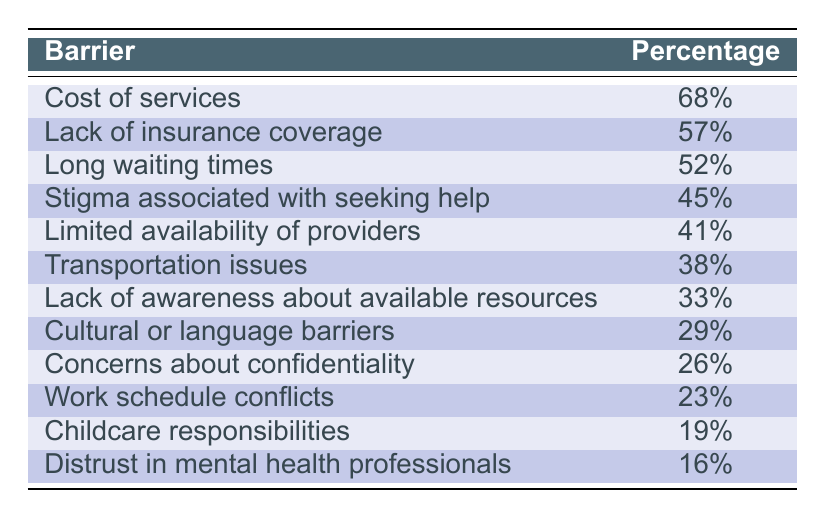What is the most commonly reported barrier to accessing mental health services? The table indicates that the "Cost of services" barrier has the highest percentage, reported by 68% of respondents.
Answer: Cost of services How many barriers have a percentage of 40% or higher? By counting the rows in the table, there are six barriers with percentages of 40% or higher: Cost of services (68%), Lack of insurance coverage (57%), Long waiting times (52%), Stigma associated with seeking help (45%), Limited availability of providers (41%).
Answer: 6 Is "Concerns about confidentiality" the least reported barrier? The "Concerns about confidentiality" barrier is reported at 26%. The least reported barrier is "Distrust in mental health professionals," with 16%. Therefore, the statement is false.
Answer: No What is the difference in percentage between the most and least reported barriers? The most reported barrier, "Cost of services," is at 68% and the least reported, "Distrust in mental health professionals," is at 16%. The difference is 68% - 16% = 52%.
Answer: 52% Which barrier has a higher percentage: "Transportation issues" or "Cultural or language barriers"? "Transportation issues" has a percentage of 38%, while "Cultural or language barriers" is at 29%. Since 38% is greater than 29%, "Transportation issues" has the higher percentage.
Answer: Transportation issues What percentage of respondents identified "Stigma associated with seeking help" and "Transportation issues" combined as barriers? The percentage for "Stigma associated with seeking help" is 45% and for "Transportation issues" it is 38%. Adding these two together gives 45% + 38% = 83%.
Answer: 83% Is the percentage of respondents citing "Work schedule conflicts" greater than that citing "Childcare responsibilities"? "Work schedule conflicts" is at 23% and "Childcare responsibilities" is at 19%. Since 23% is greater than 19%, the answer to the question is yes.
Answer: Yes What is the median percentage of the barriers listed? To find the median, we first list the percentages in ascending order as follows: [16%, 19%, 23%, 26%, 29%, 33%, 38%, 41%, 45%, 52%, 57%, 68%]. Since there are 12 values, the median is the average of the 6th and 7th values: (33% + 38%) / 2 = 35.5%.
Answer: 35.5% 